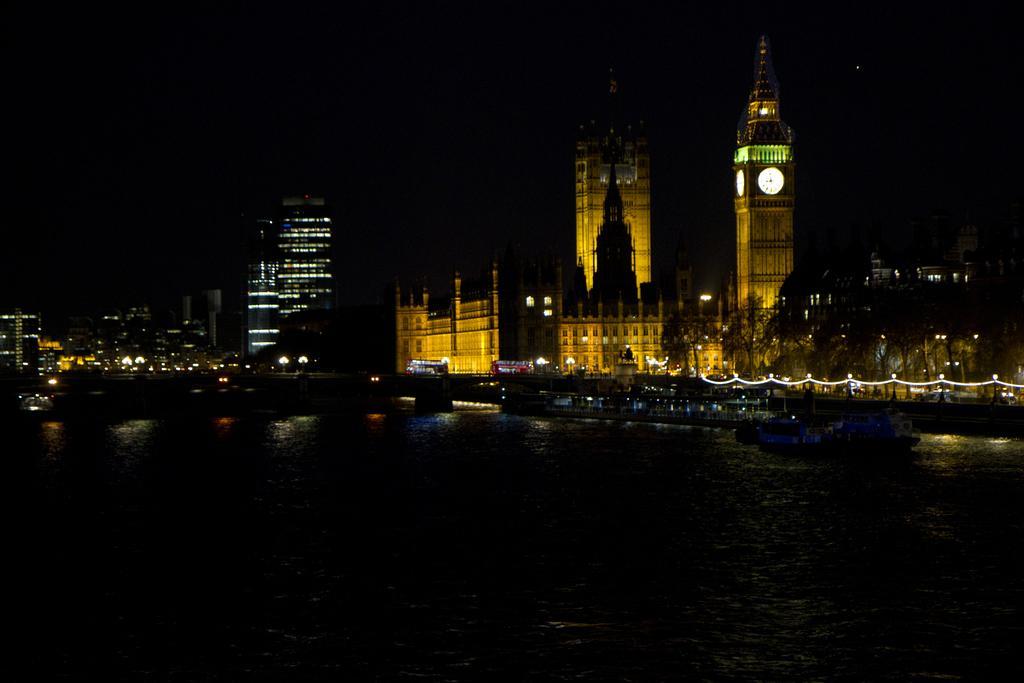Please provide a concise description of this image. In this image, we can see boats on the water and in the background, there are buildings, trees, towers, lights, vehicles on the road and there is a bridge. 